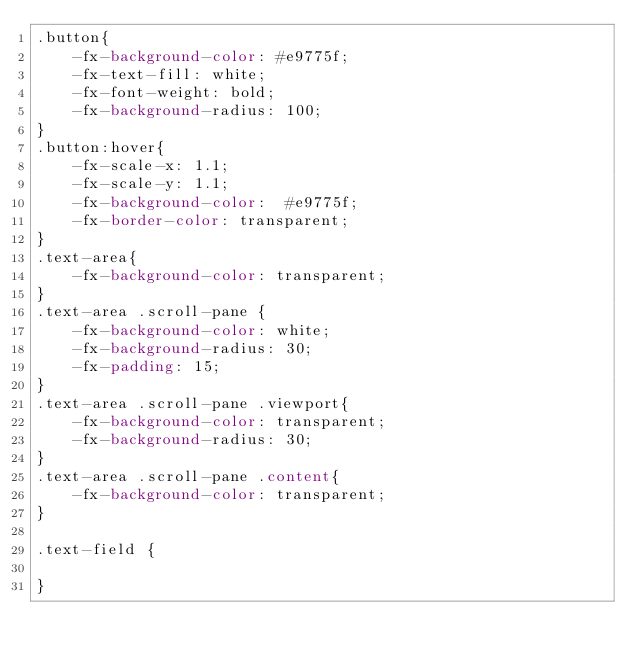Convert code to text. <code><loc_0><loc_0><loc_500><loc_500><_CSS_>.button{
    -fx-background-color: #e9775f;
    -fx-text-fill: white;
    -fx-font-weight: bold;
    -fx-background-radius: 100;
}
.button:hover{
    -fx-scale-x: 1.1;
    -fx-scale-y: 1.1;
    -fx-background-color:  #e9775f;
    -fx-border-color: transparent;
}
.text-area{
    -fx-background-color: transparent;
}
.text-area .scroll-pane {
    -fx-background-color: white;
    -fx-background-radius: 30;
    -fx-padding: 15;
}
.text-area .scroll-pane .viewport{
    -fx-background-color: transparent;
    -fx-background-radius: 30;
}
.text-area .scroll-pane .content{
    -fx-background-color: transparent;
}

.text-field {

}</code> 